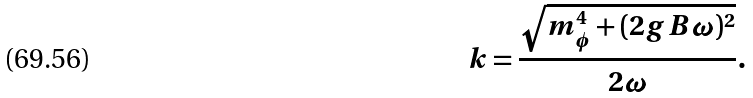Convert formula to latex. <formula><loc_0><loc_0><loc_500><loc_500>k = \frac { \sqrt { m _ { \phi } ^ { 4 } + ( 2 g B \omega ) ^ { 2 } } } { 2 \omega } .</formula> 